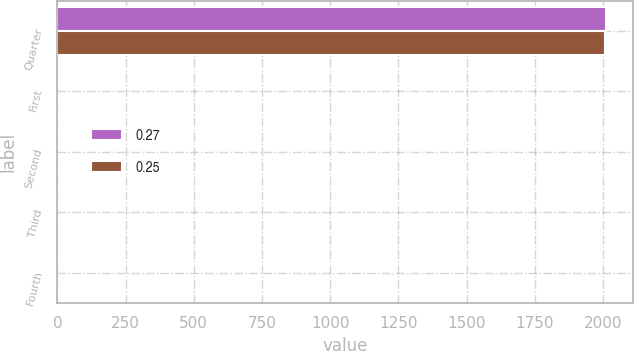Convert chart to OTSL. <chart><loc_0><loc_0><loc_500><loc_500><stacked_bar_chart><ecel><fcel>Quarter<fcel>First<fcel>Second<fcel>Third<fcel>Fourth<nl><fcel>0.27<fcel>2010<fcel>0.25<fcel>0.25<fcel>0.27<fcel>0.27<nl><fcel>0.25<fcel>2009<fcel>0.25<fcel>0.25<fcel>0.25<fcel>0.25<nl></chart> 